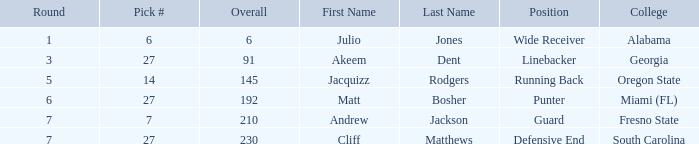Which overall's pick number was 14? 145.0. 